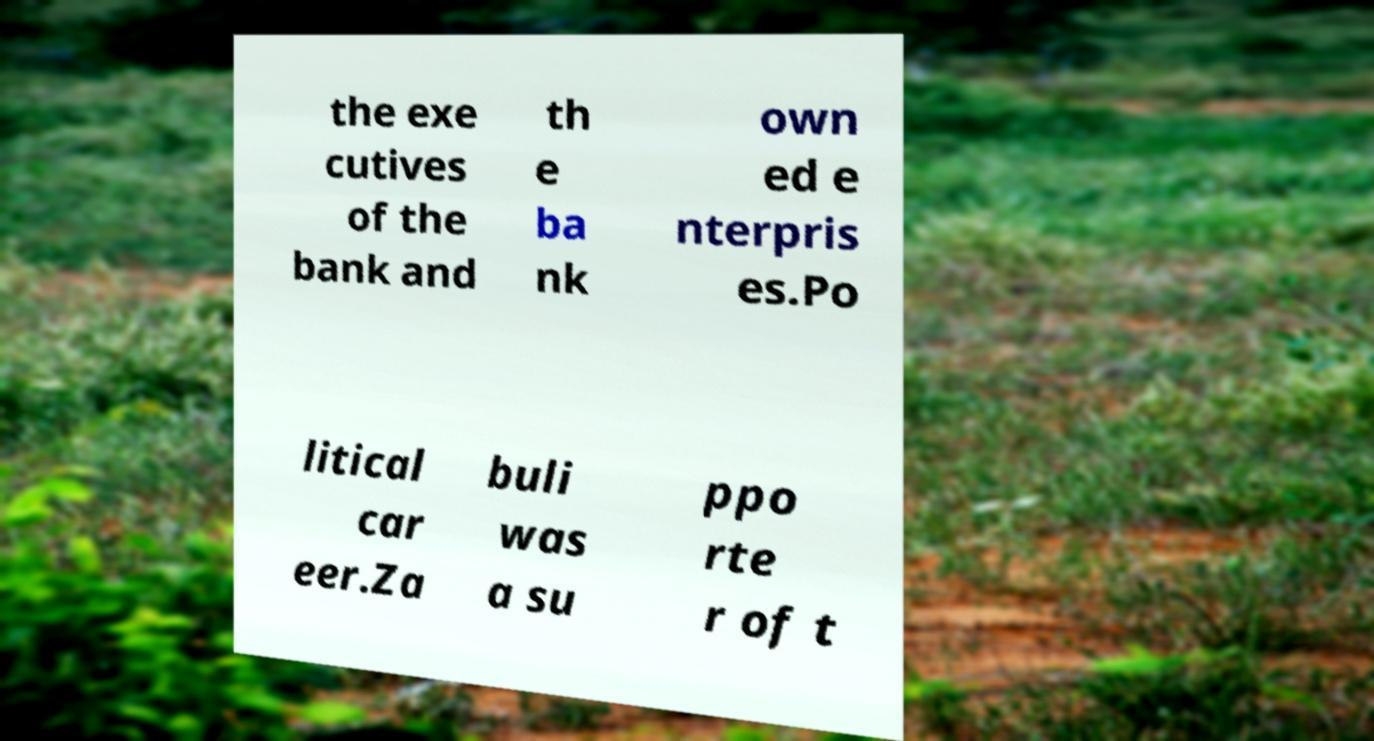Can you read and provide the text displayed in the image?This photo seems to have some interesting text. Can you extract and type it out for me? the exe cutives of the bank and th e ba nk own ed e nterpris es.Po litical car eer.Za buli was a su ppo rte r of t 